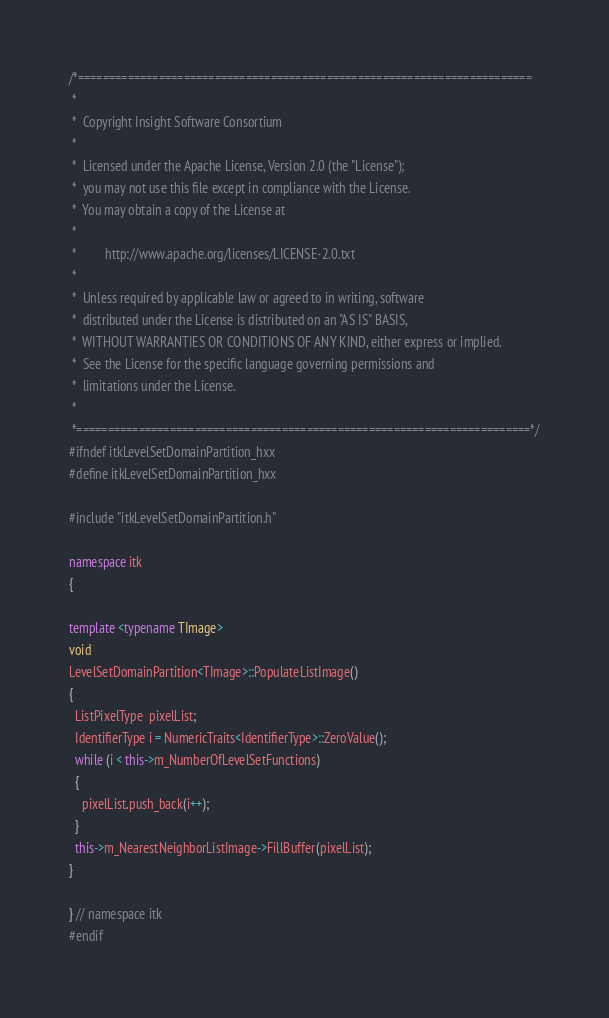Convert code to text. <code><loc_0><loc_0><loc_500><loc_500><_C++_>/*=========================================================================
 *
 *  Copyright Insight Software Consortium
 *
 *  Licensed under the Apache License, Version 2.0 (the "License");
 *  you may not use this file except in compliance with the License.
 *  You may obtain a copy of the License at
 *
 *         http://www.apache.org/licenses/LICENSE-2.0.txt
 *
 *  Unless required by applicable law or agreed to in writing, software
 *  distributed under the License is distributed on an "AS IS" BASIS,
 *  WITHOUT WARRANTIES OR CONDITIONS OF ANY KIND, either express or implied.
 *  See the License for the specific language governing permissions and
 *  limitations under the License.
 *
 *=========================================================================*/
#ifndef itkLevelSetDomainPartition_hxx
#define itkLevelSetDomainPartition_hxx

#include "itkLevelSetDomainPartition.h"

namespace itk
{

template <typename TImage>
void
LevelSetDomainPartition<TImage>::PopulateListImage()
{
  ListPixelType  pixelList;
  IdentifierType i = NumericTraits<IdentifierType>::ZeroValue();
  while (i < this->m_NumberOfLevelSetFunctions)
  {
    pixelList.push_back(i++);
  }
  this->m_NearestNeighborListImage->FillBuffer(pixelList);
}

} // namespace itk
#endif
</code> 